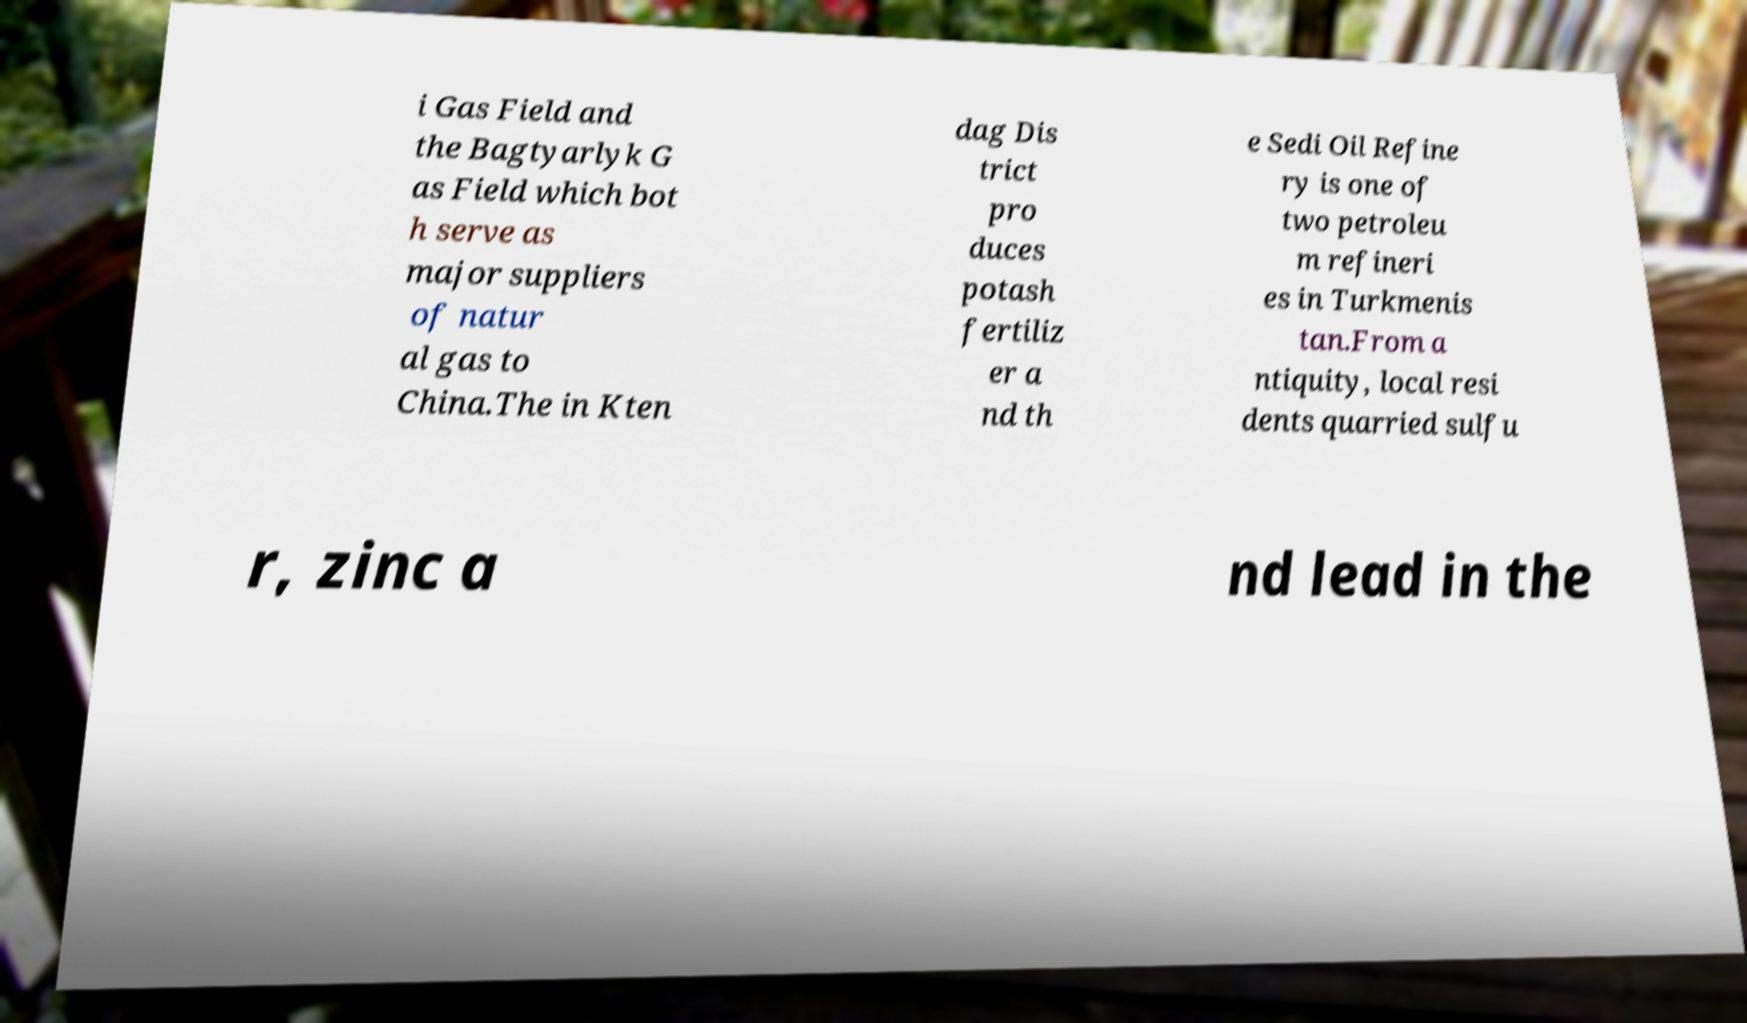There's text embedded in this image that I need extracted. Can you transcribe it verbatim? i Gas Field and the Bagtyarlyk G as Field which bot h serve as major suppliers of natur al gas to China.The in Kten dag Dis trict pro duces potash fertiliz er a nd th e Sedi Oil Refine ry is one of two petroleu m refineri es in Turkmenis tan.From a ntiquity, local resi dents quarried sulfu r, zinc a nd lead in the 